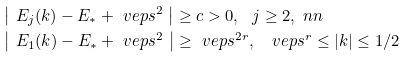<formula> <loc_0><loc_0><loc_500><loc_500>& \left | \ E _ { j } ( k ) - E _ { * } + \ v e p s ^ { 2 } \ \right | \geq c > 0 , \ \ j \geq 2 , \ n n \\ & \left | \ E _ { 1 } ( k ) - E _ { * } + \ v e p s ^ { 2 } \ \right | \geq \ v e p s ^ { 2 r } , \ \ \ v e p s ^ { r } \leq | k | \leq 1 / 2</formula> 